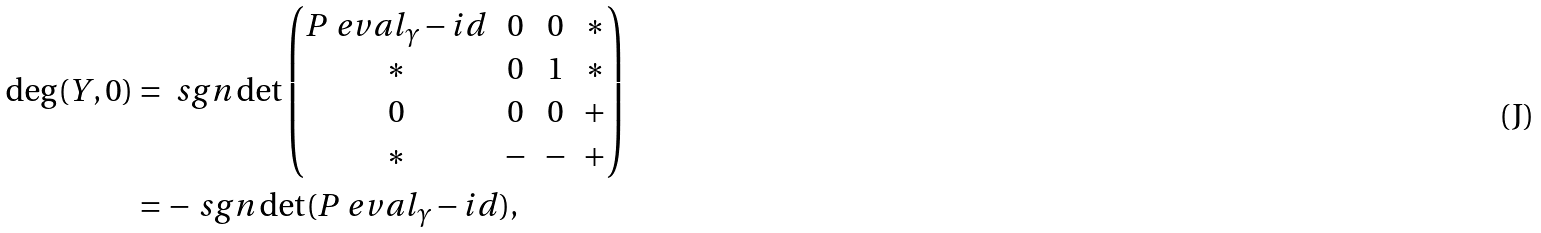Convert formula to latex. <formula><loc_0><loc_0><loc_500><loc_500>\deg ( Y , 0 ) & = \ s g n \det \begin{pmatrix} P \ e v a l _ { \gamma } - i d & 0 & 0 & * \\ * & 0 & 1 & * \\ 0 & 0 & 0 & + \\ * & - & - & + \end{pmatrix} \\ & = - \ s g n \det ( P \ e v a l _ { \gamma } - i d ) ,</formula> 